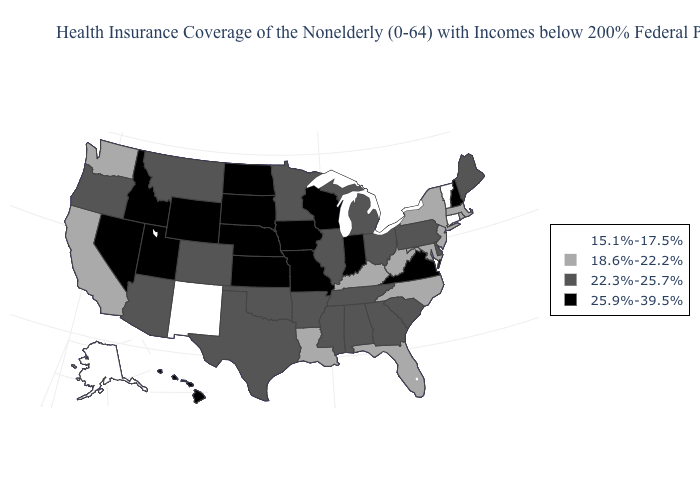Among the states that border North Carolina , which have the lowest value?
Write a very short answer. Georgia, South Carolina, Tennessee. What is the value of Connecticut?
Keep it brief. 15.1%-17.5%. Does the first symbol in the legend represent the smallest category?
Keep it brief. Yes. Name the states that have a value in the range 25.9%-39.5%?
Give a very brief answer. Hawaii, Idaho, Indiana, Iowa, Kansas, Missouri, Nebraska, Nevada, New Hampshire, North Dakota, South Dakota, Utah, Virginia, Wisconsin, Wyoming. Among the states that border California , which have the highest value?
Be succinct. Nevada. Does Missouri have a higher value than Georgia?
Concise answer only. Yes. What is the value of New York?
Keep it brief. 18.6%-22.2%. What is the highest value in the USA?
Write a very short answer. 25.9%-39.5%. Name the states that have a value in the range 22.3%-25.7%?
Give a very brief answer. Alabama, Arizona, Arkansas, Colorado, Delaware, Georgia, Illinois, Maine, Michigan, Minnesota, Mississippi, Montana, Ohio, Oklahoma, Oregon, Pennsylvania, South Carolina, Tennessee, Texas. Does Maine have the highest value in the USA?
Write a very short answer. No. Does Delaware have the same value as Wyoming?
Short answer required. No. Name the states that have a value in the range 25.9%-39.5%?
Quick response, please. Hawaii, Idaho, Indiana, Iowa, Kansas, Missouri, Nebraska, Nevada, New Hampshire, North Dakota, South Dakota, Utah, Virginia, Wisconsin, Wyoming. Does the first symbol in the legend represent the smallest category?
Write a very short answer. Yes. Which states have the lowest value in the USA?
Be succinct. Alaska, Connecticut, New Mexico, Vermont. What is the value of Hawaii?
Concise answer only. 25.9%-39.5%. 